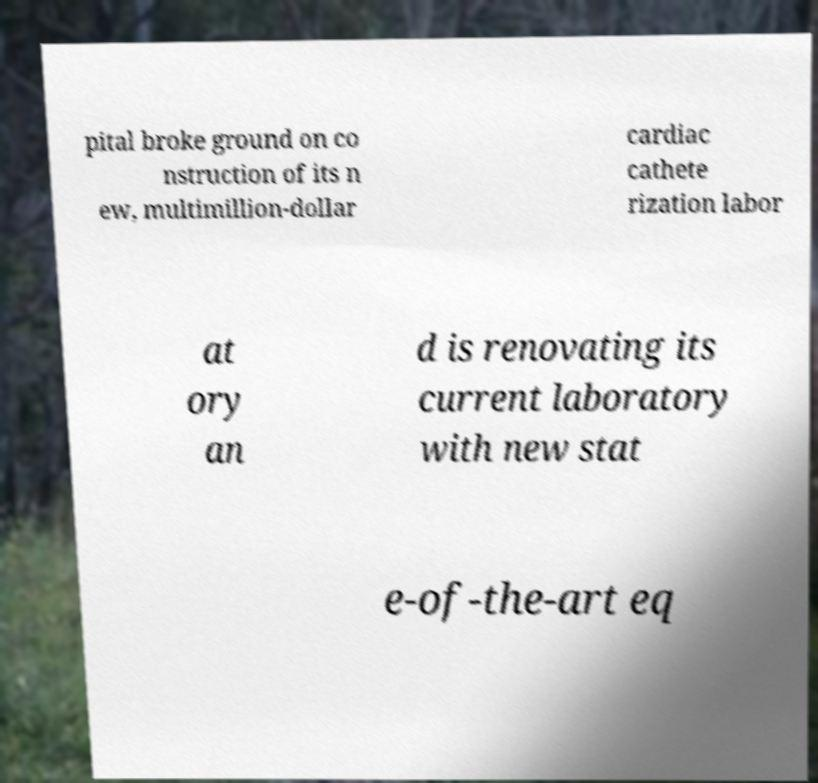There's text embedded in this image that I need extracted. Can you transcribe it verbatim? pital broke ground on co nstruction of its n ew, multimillion-dollar cardiac cathete rization labor at ory an d is renovating its current laboratory with new stat e-of-the-art eq 